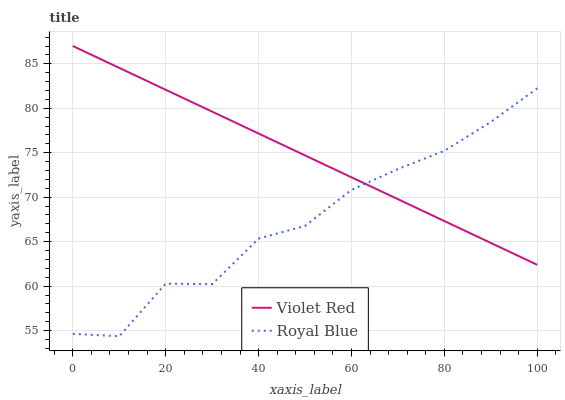Does Royal Blue have the minimum area under the curve?
Answer yes or no. Yes. Does Violet Red have the maximum area under the curve?
Answer yes or no. Yes. Does Violet Red have the minimum area under the curve?
Answer yes or no. No. Is Violet Red the smoothest?
Answer yes or no. Yes. Is Royal Blue the roughest?
Answer yes or no. Yes. Is Violet Red the roughest?
Answer yes or no. No. Does Royal Blue have the lowest value?
Answer yes or no. Yes. Does Violet Red have the lowest value?
Answer yes or no. No. Does Violet Red have the highest value?
Answer yes or no. Yes. Does Violet Red intersect Royal Blue?
Answer yes or no. Yes. Is Violet Red less than Royal Blue?
Answer yes or no. No. Is Violet Red greater than Royal Blue?
Answer yes or no. No. 